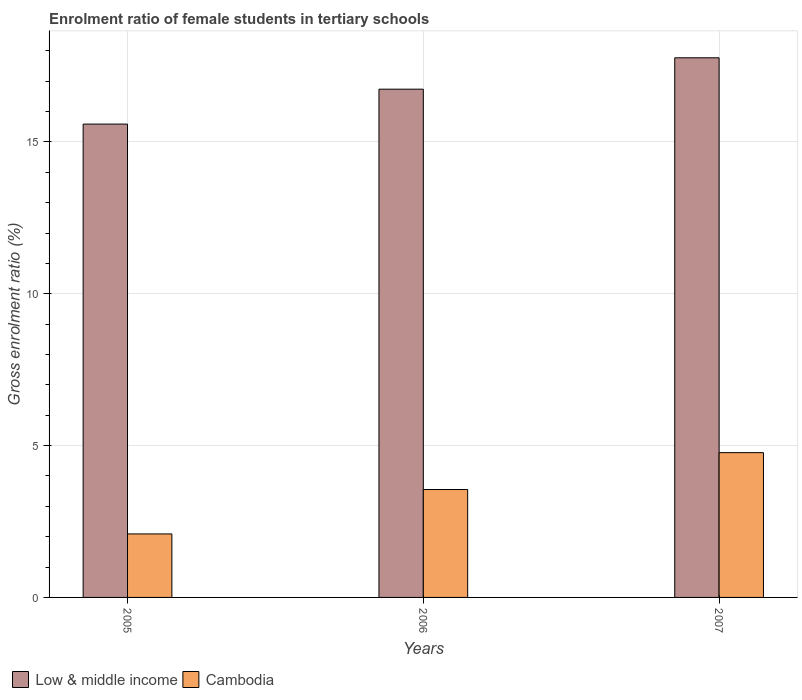How many different coloured bars are there?
Make the answer very short. 2. How many groups of bars are there?
Offer a terse response. 3. How many bars are there on the 2nd tick from the right?
Offer a terse response. 2. In how many cases, is the number of bars for a given year not equal to the number of legend labels?
Provide a short and direct response. 0. What is the enrolment ratio of female students in tertiary schools in Low & middle income in 2005?
Your answer should be very brief. 15.59. Across all years, what is the maximum enrolment ratio of female students in tertiary schools in Low & middle income?
Offer a terse response. 17.77. Across all years, what is the minimum enrolment ratio of female students in tertiary schools in Low & middle income?
Your answer should be compact. 15.59. What is the total enrolment ratio of female students in tertiary schools in Cambodia in the graph?
Keep it short and to the point. 10.41. What is the difference between the enrolment ratio of female students in tertiary schools in Low & middle income in 2005 and that in 2006?
Provide a succinct answer. -1.15. What is the difference between the enrolment ratio of female students in tertiary schools in Cambodia in 2007 and the enrolment ratio of female students in tertiary schools in Low & middle income in 2005?
Ensure brevity in your answer.  -10.82. What is the average enrolment ratio of female students in tertiary schools in Cambodia per year?
Ensure brevity in your answer.  3.47. In the year 2007, what is the difference between the enrolment ratio of female students in tertiary schools in Low & middle income and enrolment ratio of female students in tertiary schools in Cambodia?
Provide a succinct answer. 13. What is the ratio of the enrolment ratio of female students in tertiary schools in Low & middle income in 2005 to that in 2006?
Offer a very short reply. 0.93. Is the enrolment ratio of female students in tertiary schools in Cambodia in 2005 less than that in 2007?
Make the answer very short. Yes. Is the difference between the enrolment ratio of female students in tertiary schools in Low & middle income in 2005 and 2007 greater than the difference between the enrolment ratio of female students in tertiary schools in Cambodia in 2005 and 2007?
Keep it short and to the point. Yes. What is the difference between the highest and the second highest enrolment ratio of female students in tertiary schools in Cambodia?
Your response must be concise. 1.21. What is the difference between the highest and the lowest enrolment ratio of female students in tertiary schools in Low & middle income?
Your answer should be compact. 2.18. What does the 1st bar from the left in 2005 represents?
Give a very brief answer. Low & middle income. What does the 2nd bar from the right in 2006 represents?
Your answer should be compact. Low & middle income. How many bars are there?
Offer a very short reply. 6. Are all the bars in the graph horizontal?
Provide a succinct answer. No. Does the graph contain any zero values?
Provide a succinct answer. No. Does the graph contain grids?
Your answer should be very brief. Yes. How many legend labels are there?
Your response must be concise. 2. How are the legend labels stacked?
Offer a terse response. Horizontal. What is the title of the graph?
Your answer should be very brief. Enrolment ratio of female students in tertiary schools. Does "Malta" appear as one of the legend labels in the graph?
Your answer should be compact. No. What is the label or title of the X-axis?
Your response must be concise. Years. What is the label or title of the Y-axis?
Provide a short and direct response. Gross enrolment ratio (%). What is the Gross enrolment ratio (%) of Low & middle income in 2005?
Provide a succinct answer. 15.59. What is the Gross enrolment ratio (%) in Cambodia in 2005?
Offer a terse response. 2.09. What is the Gross enrolment ratio (%) of Low & middle income in 2006?
Keep it short and to the point. 16.74. What is the Gross enrolment ratio (%) in Cambodia in 2006?
Provide a succinct answer. 3.55. What is the Gross enrolment ratio (%) of Low & middle income in 2007?
Give a very brief answer. 17.77. What is the Gross enrolment ratio (%) in Cambodia in 2007?
Offer a very short reply. 4.77. Across all years, what is the maximum Gross enrolment ratio (%) of Low & middle income?
Your answer should be very brief. 17.77. Across all years, what is the maximum Gross enrolment ratio (%) of Cambodia?
Offer a terse response. 4.77. Across all years, what is the minimum Gross enrolment ratio (%) in Low & middle income?
Ensure brevity in your answer.  15.59. Across all years, what is the minimum Gross enrolment ratio (%) in Cambodia?
Offer a terse response. 2.09. What is the total Gross enrolment ratio (%) in Low & middle income in the graph?
Give a very brief answer. 50.1. What is the total Gross enrolment ratio (%) in Cambodia in the graph?
Your response must be concise. 10.41. What is the difference between the Gross enrolment ratio (%) of Low & middle income in 2005 and that in 2006?
Provide a succinct answer. -1.15. What is the difference between the Gross enrolment ratio (%) of Cambodia in 2005 and that in 2006?
Your response must be concise. -1.46. What is the difference between the Gross enrolment ratio (%) in Low & middle income in 2005 and that in 2007?
Give a very brief answer. -2.18. What is the difference between the Gross enrolment ratio (%) in Cambodia in 2005 and that in 2007?
Offer a terse response. -2.68. What is the difference between the Gross enrolment ratio (%) of Low & middle income in 2006 and that in 2007?
Your answer should be compact. -1.03. What is the difference between the Gross enrolment ratio (%) of Cambodia in 2006 and that in 2007?
Give a very brief answer. -1.21. What is the difference between the Gross enrolment ratio (%) in Low & middle income in 2005 and the Gross enrolment ratio (%) in Cambodia in 2006?
Ensure brevity in your answer.  12.03. What is the difference between the Gross enrolment ratio (%) in Low & middle income in 2005 and the Gross enrolment ratio (%) in Cambodia in 2007?
Offer a very short reply. 10.82. What is the difference between the Gross enrolment ratio (%) in Low & middle income in 2006 and the Gross enrolment ratio (%) in Cambodia in 2007?
Your response must be concise. 11.97. What is the average Gross enrolment ratio (%) of Low & middle income per year?
Offer a terse response. 16.7. What is the average Gross enrolment ratio (%) in Cambodia per year?
Ensure brevity in your answer.  3.47. In the year 2005, what is the difference between the Gross enrolment ratio (%) of Low & middle income and Gross enrolment ratio (%) of Cambodia?
Ensure brevity in your answer.  13.5. In the year 2006, what is the difference between the Gross enrolment ratio (%) in Low & middle income and Gross enrolment ratio (%) in Cambodia?
Give a very brief answer. 13.18. In the year 2007, what is the difference between the Gross enrolment ratio (%) in Low & middle income and Gross enrolment ratio (%) in Cambodia?
Your answer should be compact. 13. What is the ratio of the Gross enrolment ratio (%) of Low & middle income in 2005 to that in 2006?
Your answer should be very brief. 0.93. What is the ratio of the Gross enrolment ratio (%) of Cambodia in 2005 to that in 2006?
Keep it short and to the point. 0.59. What is the ratio of the Gross enrolment ratio (%) in Low & middle income in 2005 to that in 2007?
Your answer should be compact. 0.88. What is the ratio of the Gross enrolment ratio (%) of Cambodia in 2005 to that in 2007?
Your response must be concise. 0.44. What is the ratio of the Gross enrolment ratio (%) in Low & middle income in 2006 to that in 2007?
Provide a succinct answer. 0.94. What is the ratio of the Gross enrolment ratio (%) in Cambodia in 2006 to that in 2007?
Your answer should be compact. 0.75. What is the difference between the highest and the second highest Gross enrolment ratio (%) of Low & middle income?
Your answer should be very brief. 1.03. What is the difference between the highest and the second highest Gross enrolment ratio (%) of Cambodia?
Your answer should be very brief. 1.21. What is the difference between the highest and the lowest Gross enrolment ratio (%) in Low & middle income?
Offer a terse response. 2.18. What is the difference between the highest and the lowest Gross enrolment ratio (%) in Cambodia?
Offer a terse response. 2.68. 